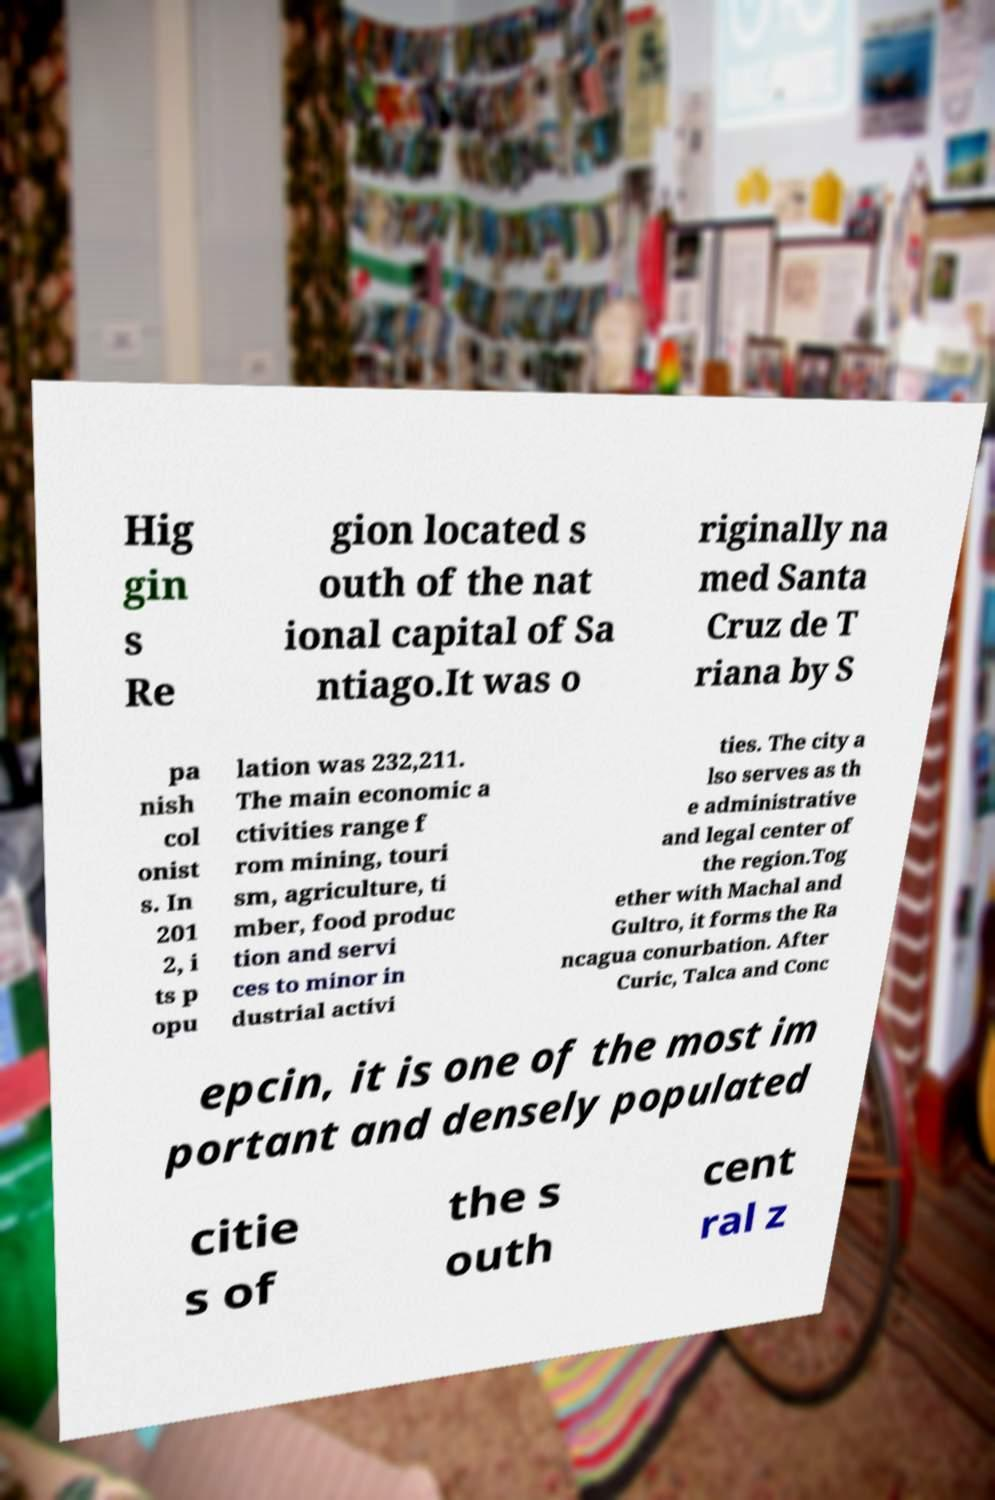I need the written content from this picture converted into text. Can you do that? Hig gin s Re gion located s outh of the nat ional capital of Sa ntiago.It was o riginally na med Santa Cruz de T riana by S pa nish col onist s. In 201 2, i ts p opu lation was 232,211. The main economic a ctivities range f rom mining, touri sm, agriculture, ti mber, food produc tion and servi ces to minor in dustrial activi ties. The city a lso serves as th e administrative and legal center of the region.Tog ether with Machal and Gultro, it forms the Ra ncagua conurbation. After Curic, Talca and Conc epcin, it is one of the most im portant and densely populated citie s of the s outh cent ral z 